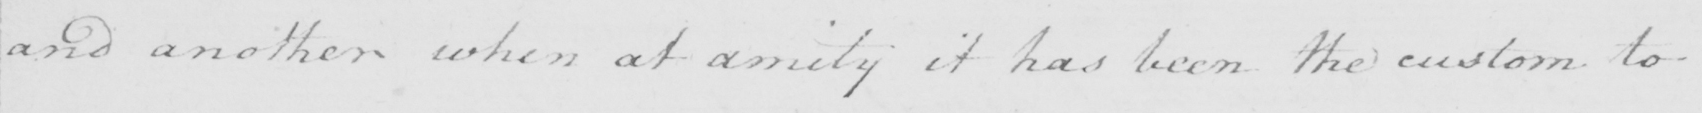Please provide the text content of this handwritten line. and another when at amity it has been the custom to 